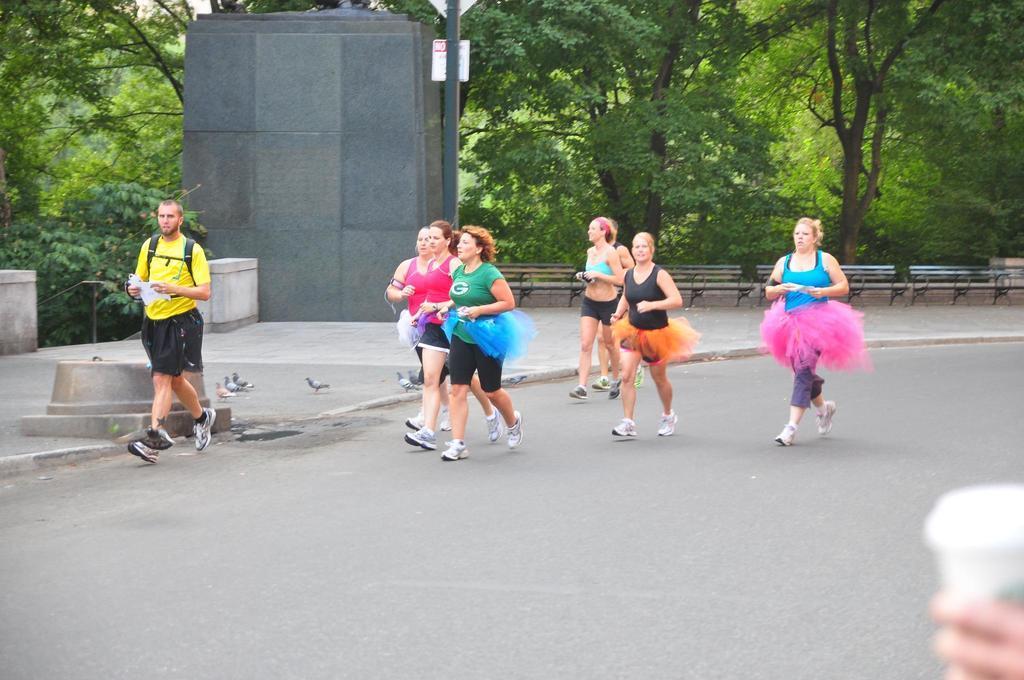Can you describe this image briefly? In this image we can see a group of women running on the road. Here we can see a man on the left side. Here we can see a pole and benches on the side of the road. Here we can see the pigeons on the side of the road. Here we can see the hand of a person holding the glass on the bottom right side. 